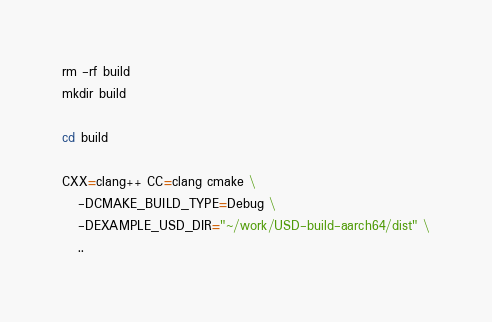<code> <loc_0><loc_0><loc_500><loc_500><_Bash_>rm -rf build
mkdir build

cd build

CXX=clang++ CC=clang cmake \
   -DCMAKE_BUILD_TYPE=Debug \
   -DEXAMPLE_USD_DIR="~/work/USD-build-aarch64/dist" \
   ..
</code> 